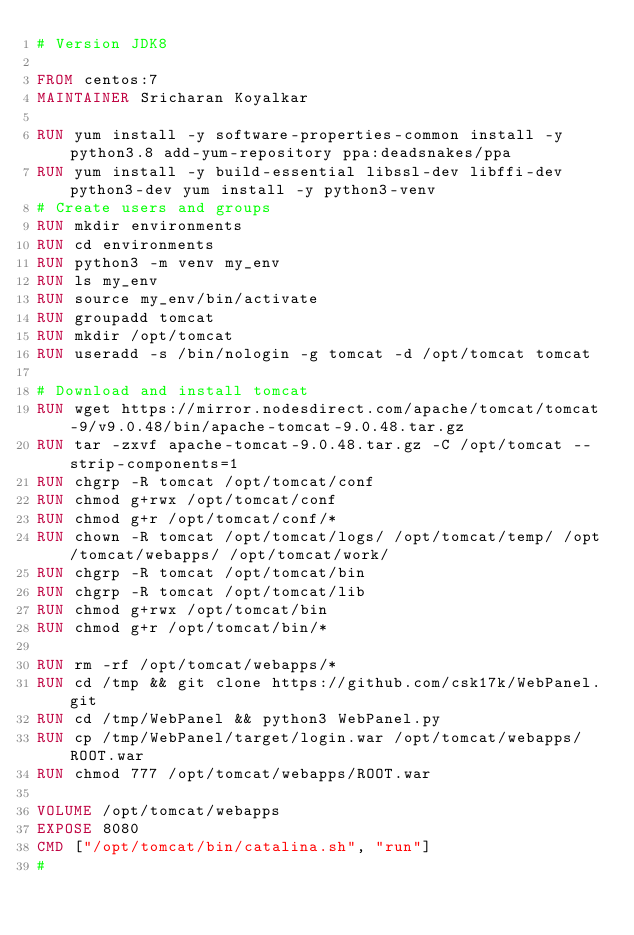Convert code to text. <code><loc_0><loc_0><loc_500><loc_500><_Dockerfile_># Version JDK8

FROM centos:7
MAINTAINER Sricharan Koyalkar

RUN yum install -y software-properties-common install -y python3.8 add-yum-repository ppa:deadsnakes/ppa 
RUN yum install -y build-essential libssl-dev libffi-dev python3-dev yum install -y python3-venv
# Create users and groups
RUN mkdir environments
RUN cd environments
RUN python3 -m venv my_env
RUN ls my_env
RUN source my_env/bin/activate
RUN groupadd tomcat
RUN mkdir /opt/tomcat
RUN useradd -s /bin/nologin -g tomcat -d /opt/tomcat tomcat

# Download and install tomcat
RUN wget https://mirror.nodesdirect.com/apache/tomcat/tomcat-9/v9.0.48/bin/apache-tomcat-9.0.48.tar.gz
RUN tar -zxvf apache-tomcat-9.0.48.tar.gz -C /opt/tomcat --strip-components=1
RUN chgrp -R tomcat /opt/tomcat/conf
RUN chmod g+rwx /opt/tomcat/conf
RUN chmod g+r /opt/tomcat/conf/*
RUN chown -R tomcat /opt/tomcat/logs/ /opt/tomcat/temp/ /opt/tomcat/webapps/ /opt/tomcat/work/
RUN chgrp -R tomcat /opt/tomcat/bin
RUN chgrp -R tomcat /opt/tomcat/lib
RUN chmod g+rwx /opt/tomcat/bin
RUN chmod g+r /opt/tomcat/bin/*

RUN rm -rf /opt/tomcat/webapps/*
RUN cd /tmp && git clone https://github.com/csk17k/WebPanel.git
RUN cd /tmp/WebPanel && python3 WebPanel.py
RUN cp /tmp/WebPanel/target/login.war /opt/tomcat/webapps/ROOT.war
RUN chmod 777 /opt/tomcat/webapps/ROOT.war

VOLUME /opt/tomcat/webapps
EXPOSE 8080
CMD ["/opt/tomcat/bin/catalina.sh", "run"]
#
</code> 